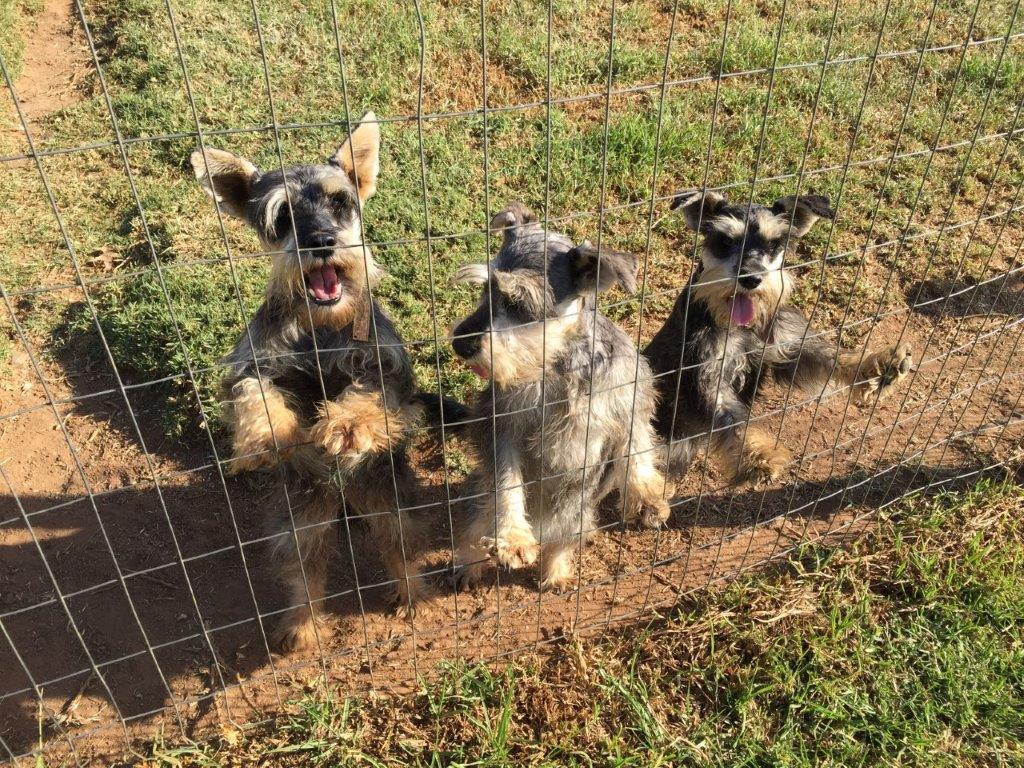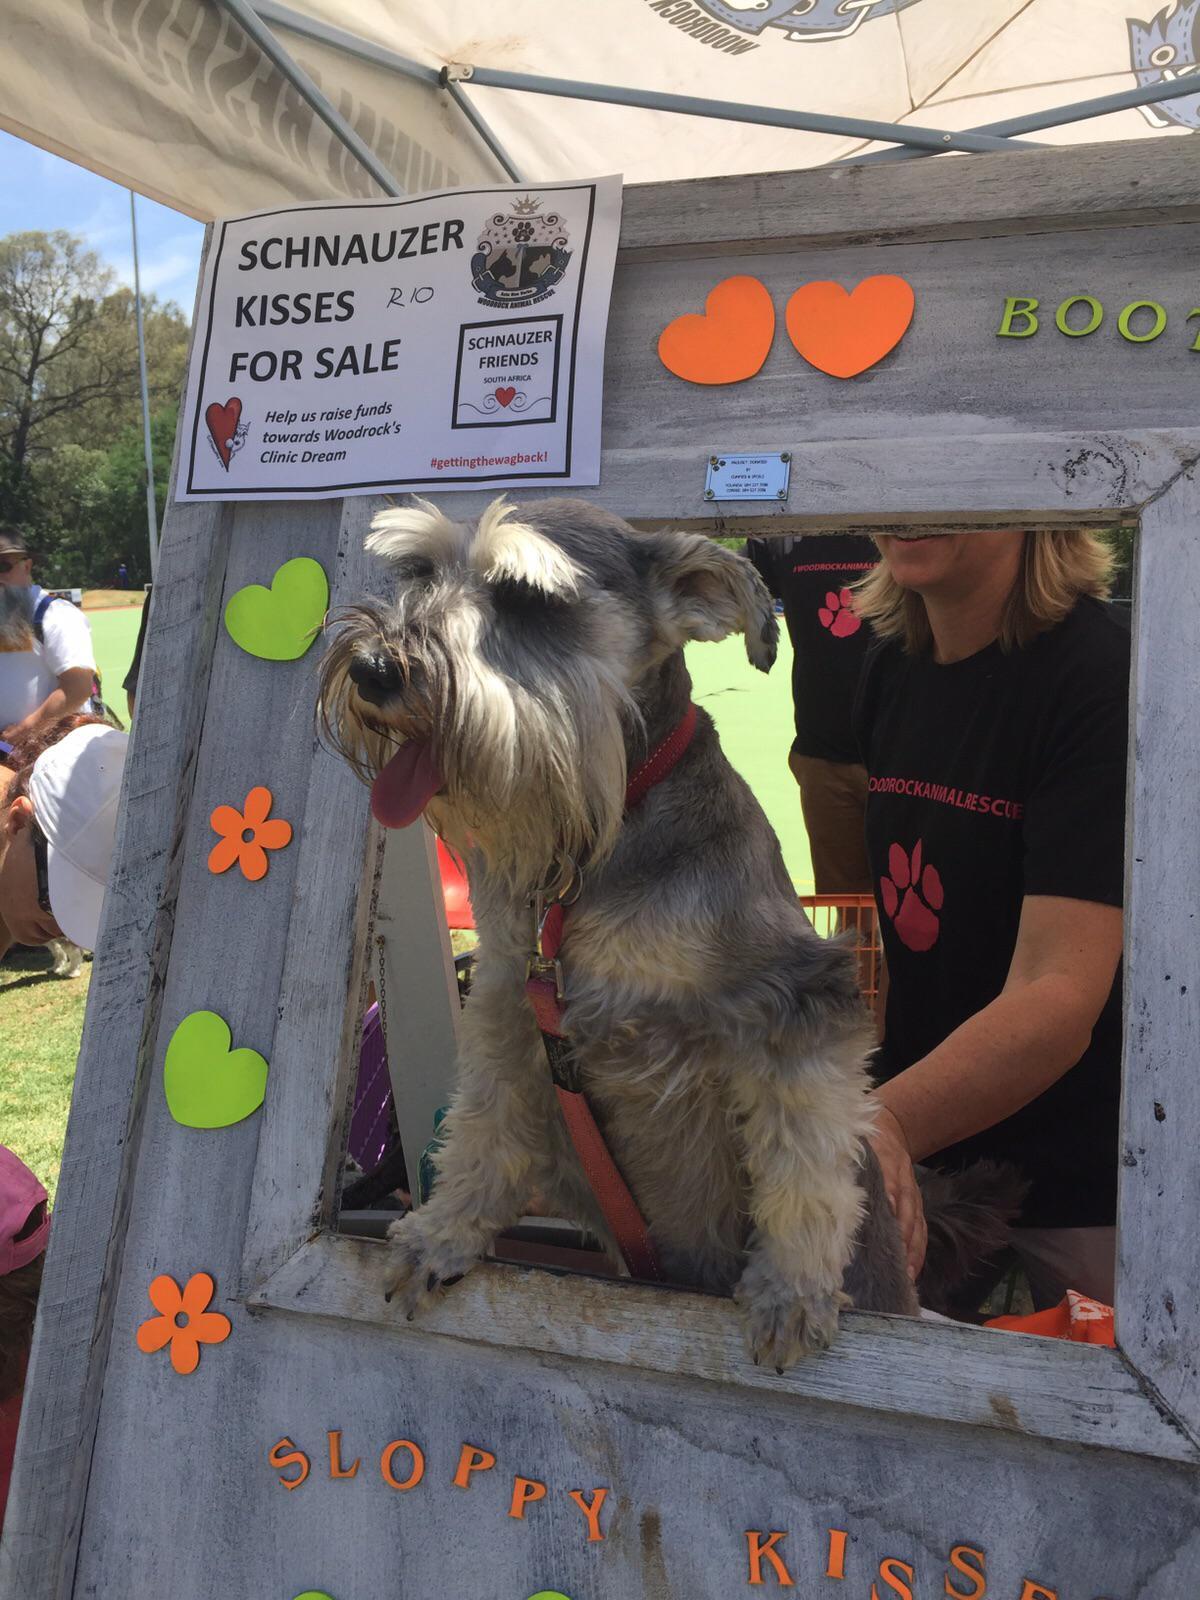The first image is the image on the left, the second image is the image on the right. Considering the images on both sides, is "At least 4 dogs are standing behind a fence looking out." valid? Answer yes or no. No. The first image is the image on the left, the second image is the image on the right. Examine the images to the left and right. Is the description "there are no more than 4 dogs behind a wire fence in the image pair" accurate? Answer yes or no. Yes. 